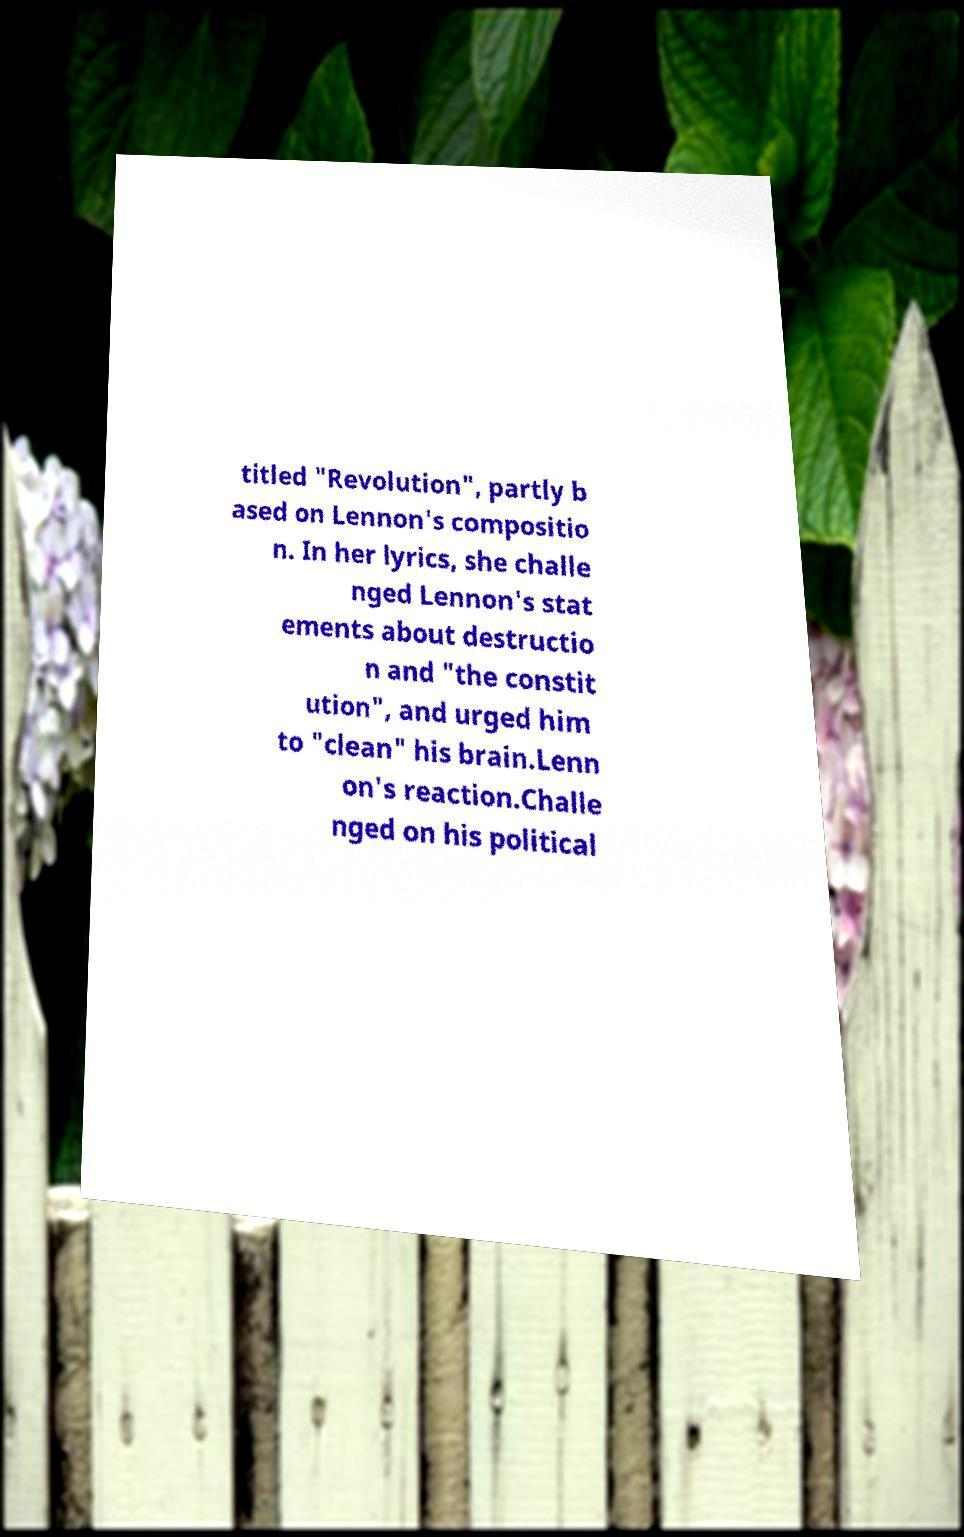Can you read and provide the text displayed in the image?This photo seems to have some interesting text. Can you extract and type it out for me? titled "Revolution", partly b ased on Lennon's compositio n. In her lyrics, she challe nged Lennon's stat ements about destructio n and "the constit ution", and urged him to "clean" his brain.Lenn on's reaction.Challe nged on his political 